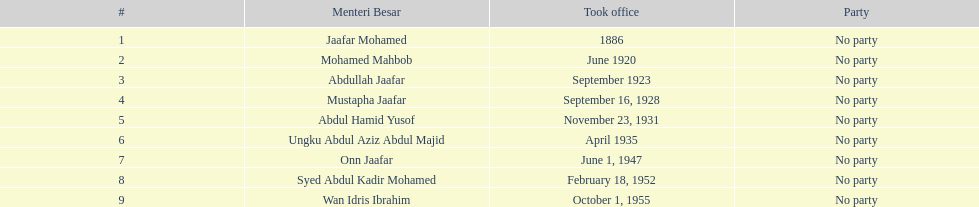Name someone who was not in office more than 4 years. Mohamed Mahbob. 